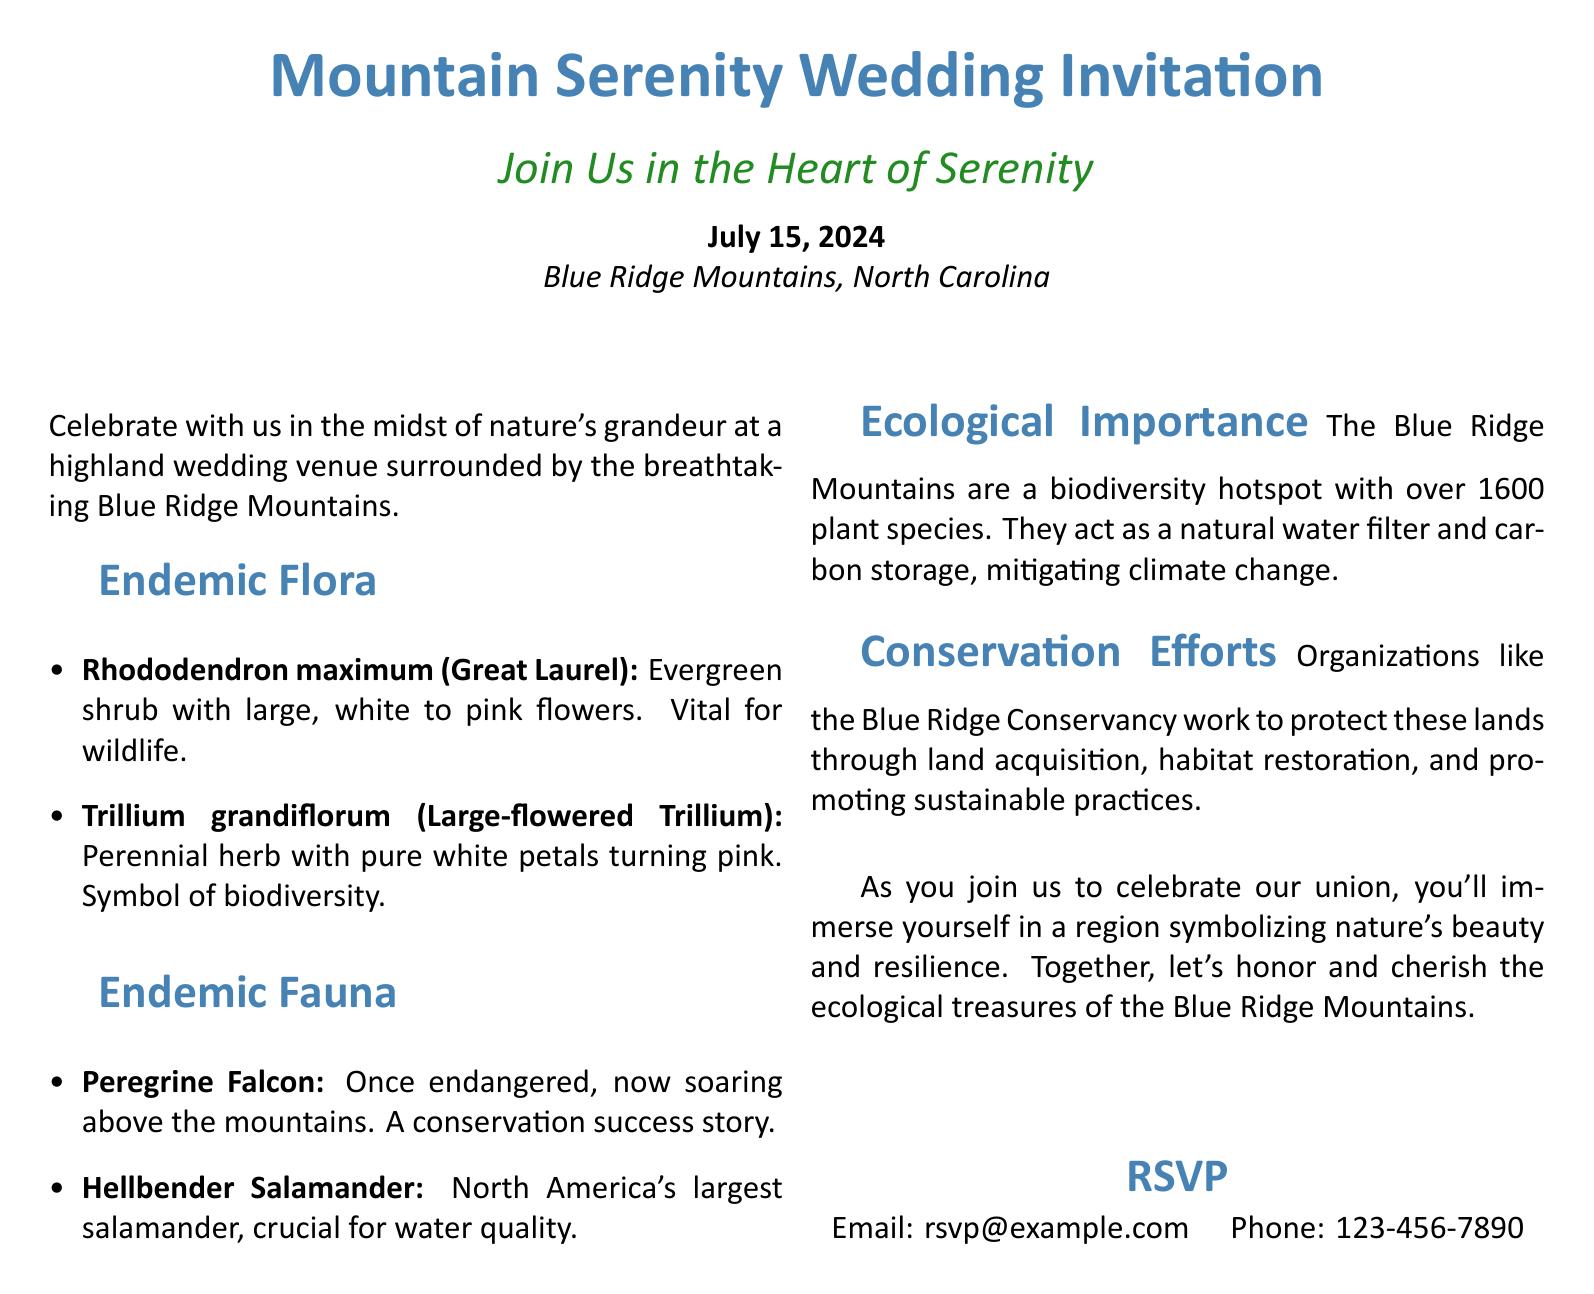What is the date of the wedding? The date is listed in the document as the main event date, which is July 15, 2024.
Answer: July 15, 2024 Where is the wedding venue located? The venue is specified in the document, which mentions the Blue Ridge Mountains, North Carolina.
Answer: Blue Ridge Mountains, North Carolina What is the first endemic flora mentioned? The first endemic flora is highlighted in the list of plants under the "Endemic Flora" section, which is Rhododendron maximum.
Answer: Rhododendron maximum Which conservation organization is mentioned? The document specifically names the Blue Ridge Conservancy in the "Conservation Efforts" section.
Answer: Blue Ridge Conservancy What is the ecological significance of the Blue Ridge Mountains? The document states that the Blue Ridge Mountains act as a natural water filter and carbon storage, which is their ecological importance.
Answer: Natural water filter and carbon storage How many plant species are in the Blue Ridge Mountains? The document provides a numerical value for the plant species, stating there are over 1600 species.
Answer: Over 1600 What animal is described as a conservation success story? The document indicates that the Peregrine Falcon is a conservation success story mentioned under "Endemic Fauna."
Answer: Peregrine Falcon What does the RSVP section include? The RSVP section provides contact information for responding to the invitation, including an email and phone number.
Answer: Email: rsvp@example.com, Phone: 123-456-7890 